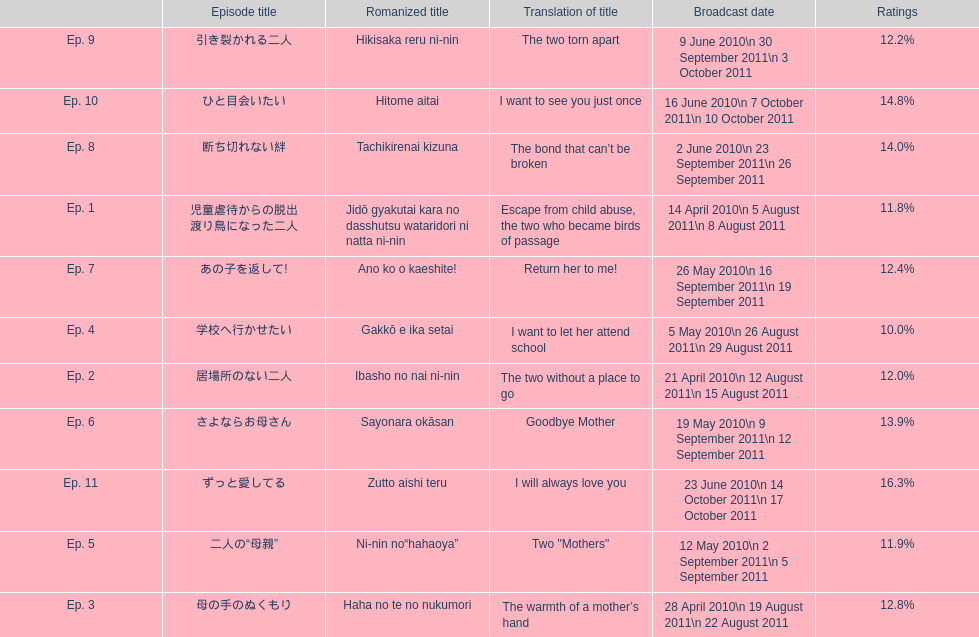I'm looking to parse the entire table for insights. Could you assist me with that? {'header': ['', 'Episode title', 'Romanized title', 'Translation of title', 'Broadcast date', 'Ratings'], 'rows': [['Ep. 9', '引き裂かれる二人', 'Hikisaka reru ni-nin', 'The two torn apart', '9 June 2010\\n 30 September 2011\\n 3 October 2011', '12.2%'], ['Ep. 10', 'ひと目会いたい', 'Hitome aitai', 'I want to see you just once', '16 June 2010\\n 7 October 2011\\n 10 October 2011', '14.8%'], ['Ep. 8', '断ち切れない絆', 'Tachikirenai kizuna', 'The bond that can’t be broken', '2 June 2010\\n 23 September 2011\\n 26 September 2011', '14.0%'], ['Ep. 1', '児童虐待からの脱出 渡り鳥になった二人', 'Jidō gyakutai kara no dasshutsu wataridori ni natta ni-nin', 'Escape from child abuse, the two who became birds of passage', '14 April 2010\\n 5 August 2011\\n 8 August 2011', '11.8%'], ['Ep. 7', 'あの子を返して!', 'Ano ko o kaeshite!', 'Return her to me!', '26 May 2010\\n 16 September 2011\\n 19 September 2011', '12.4%'], ['Ep. 4', '学校へ行かせたい', 'Gakkō e ika setai', 'I want to let her attend school', '5 May 2010\\n 26 August 2011\\n 29 August 2011', '10.0%'], ['Ep. 2', '居場所のない二人', 'Ibasho no nai ni-nin', 'The two without a place to go', '21 April 2010\\n 12 August 2011\\n 15 August 2011', '12.0%'], ['Ep. 6', 'さよならお母さん', 'Sayonara okāsan', 'Goodbye Mother', '19 May 2010\\n 9 September 2011\\n 12 September 2011', '13.9%'], ['Ep. 11', 'ずっと愛してる', 'Zutto aishi teru', 'I will always love you', '23 June 2010\\n 14 October 2011\\n 17 October 2011', '16.3%'], ['Ep. 5', '二人の“母親”', 'Ni-nin no“hahaoya”', 'Two "Mothers"', '12 May 2010\\n 2 September 2011\\n 5 September 2011', '11.9%'], ['Ep. 3', '母の手のぬくもり', 'Haha no te no nukumori', 'The warmth of a mother’s hand', '28 April 2010\\n 19 August 2011\\n 22 August 2011', '12.8%']]} How many episodes were shown in japan during april 2010? 3. 